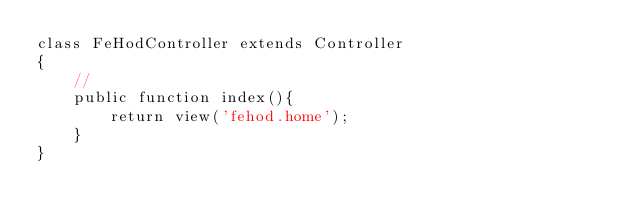Convert code to text. <code><loc_0><loc_0><loc_500><loc_500><_PHP_>class FeHodController extends Controller
{
    //
    public function index(){
        return view('fehod.home');
    }
}
</code> 